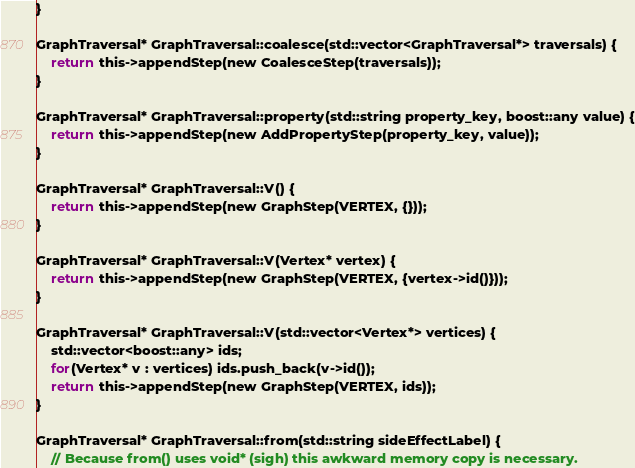Convert code to text. <code><loc_0><loc_0><loc_500><loc_500><_C_>}

GraphTraversal* GraphTraversal::coalesce(std::vector<GraphTraversal*> traversals) {
	return this->appendStep(new CoalesceStep(traversals));
}

GraphTraversal* GraphTraversal::property(std::string property_key, boost::any value) {
	return this->appendStep(new AddPropertyStep(property_key, value));
}

GraphTraversal* GraphTraversal::V() {
	return this->appendStep(new GraphStep(VERTEX, {}));
}

GraphTraversal* GraphTraversal::V(Vertex* vertex) {
	return this->appendStep(new GraphStep(VERTEX, {vertex->id()}));
}

GraphTraversal* GraphTraversal::V(std::vector<Vertex*> vertices) {
	std::vector<boost::any> ids;
	for(Vertex* v : vertices) ids.push_back(v->id());
	return this->appendStep(new GraphStep(VERTEX, ids));
}

GraphTraversal* GraphTraversal::from(std::string sideEffectLabel) {
	// Because from() uses void* (sigh) this awkward memory copy is necessary.</code> 